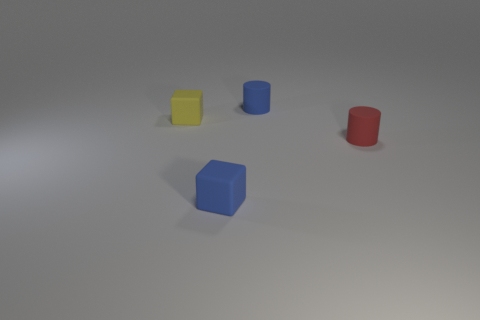Are there an equal number of tiny blocks that are behind the tiny red rubber object and yellow blocks?
Keep it short and to the point. Yes. Is there anything else that has the same size as the blue block?
Your answer should be compact. Yes. What number of objects are either tiny things or red cylinders?
Your response must be concise. 4. There is a small red thing that is made of the same material as the tiny blue block; what is its shape?
Ensure brevity in your answer.  Cylinder. What is the size of the blue matte object to the right of the blue matte thing that is in front of the blue cylinder?
Make the answer very short. Small. How many tiny objects are either cylinders or blue objects?
Ensure brevity in your answer.  3. Do the matte cube that is in front of the red rubber cylinder and the cylinder behind the red matte thing have the same size?
Make the answer very short. Yes. Are there more objects that are on the right side of the tiny red cylinder than blue matte cylinders that are left of the blue matte block?
Offer a very short reply. No. What color is the matte cylinder behind the small red rubber cylinder that is in front of the small blue rubber cylinder?
Keep it short and to the point. Blue. How many cylinders are either tiny gray rubber things or small objects?
Make the answer very short. 2. 